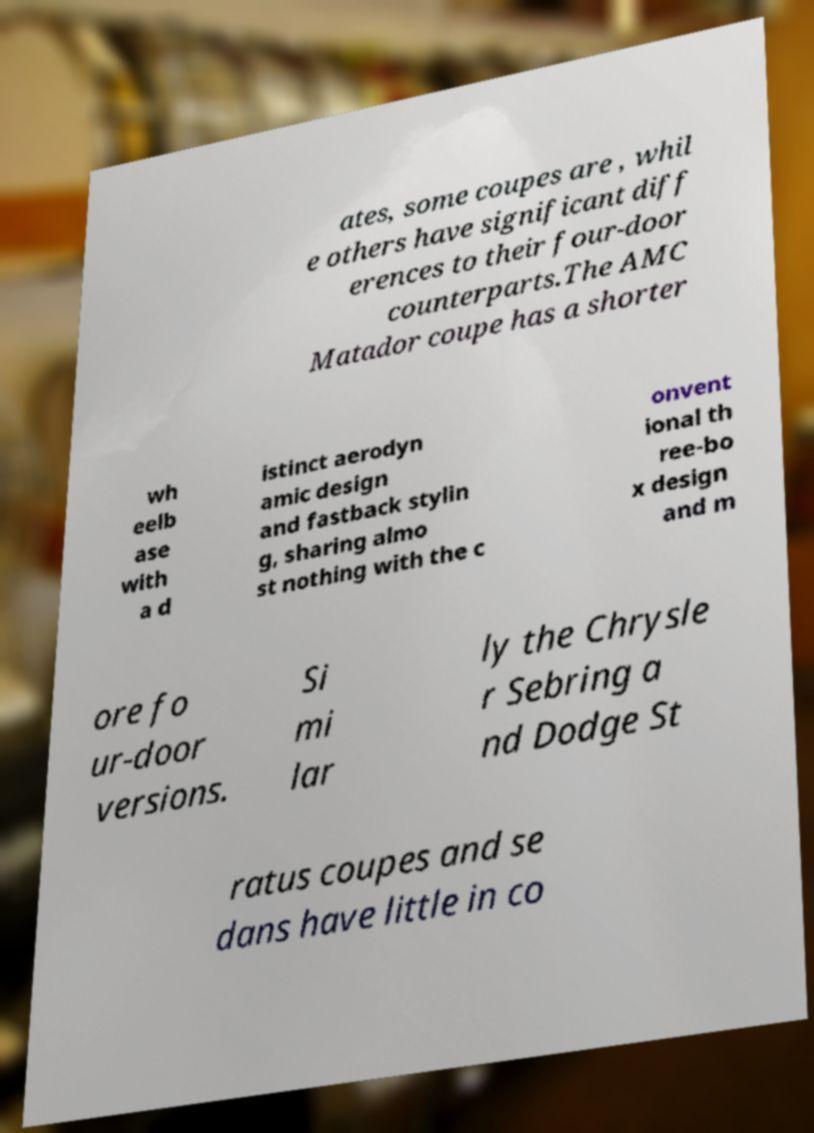For documentation purposes, I need the text within this image transcribed. Could you provide that? ates, some coupes are , whil e others have significant diff erences to their four-door counterparts.The AMC Matador coupe has a shorter wh eelb ase with a d istinct aerodyn amic design and fastback stylin g, sharing almo st nothing with the c onvent ional th ree-bo x design and m ore fo ur-door versions. Si mi lar ly the Chrysle r Sebring a nd Dodge St ratus coupes and se dans have little in co 